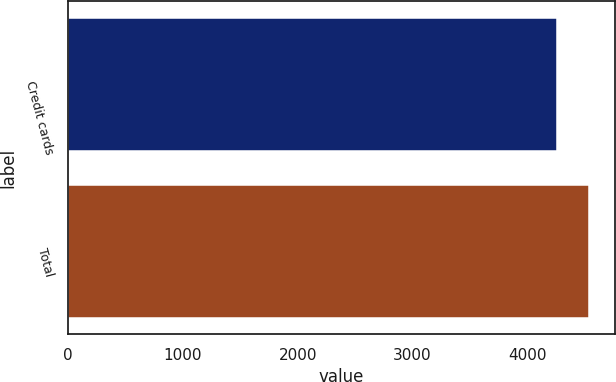<chart> <loc_0><loc_0><loc_500><loc_500><bar_chart><fcel>Credit cards<fcel>Total<nl><fcel>4263<fcel>4537<nl></chart> 